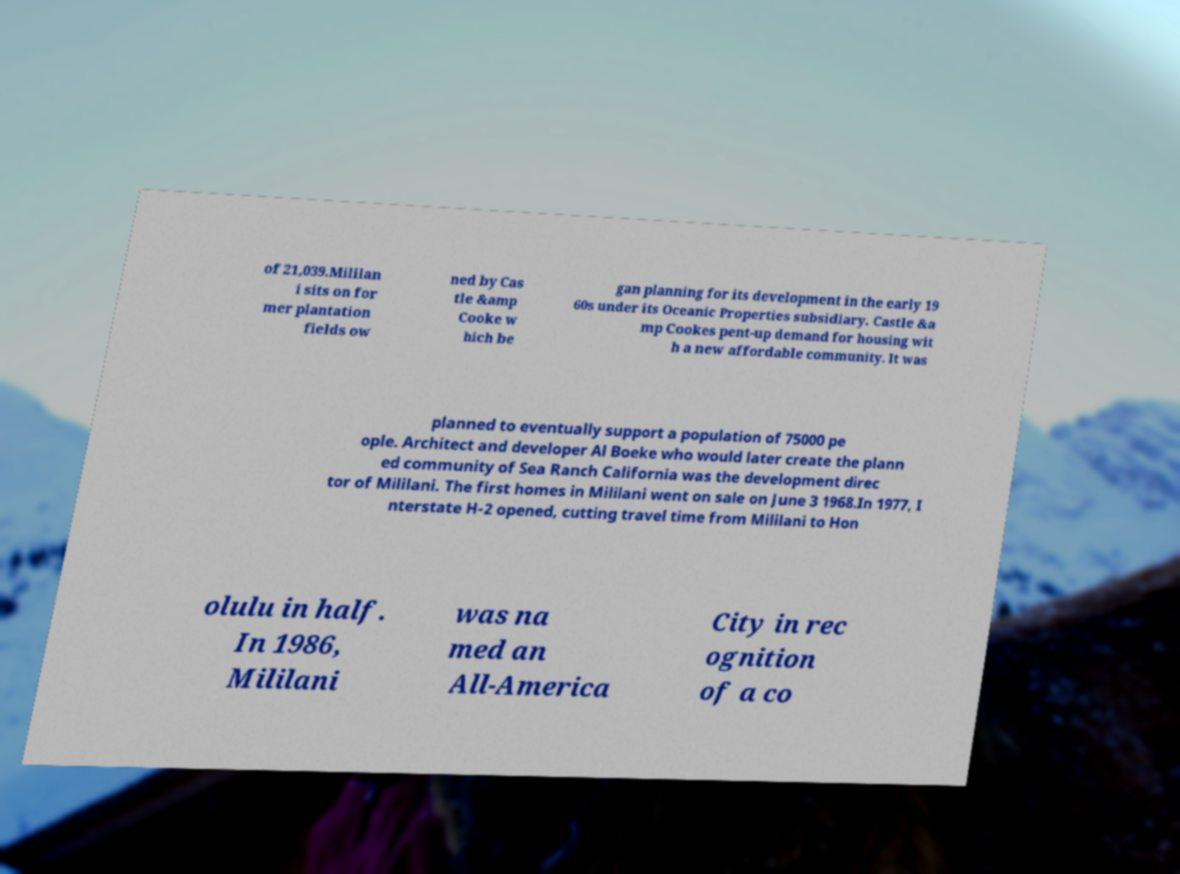Can you accurately transcribe the text from the provided image for me? of 21,039.Mililan i sits on for mer plantation fields ow ned by Cas tle &amp Cooke w hich be gan planning for its development in the early 19 60s under its Oceanic Properties subsidiary. Castle &a mp Cookes pent-up demand for housing wit h a new affordable community. It was planned to eventually support a population of 75000 pe ople. Architect and developer Al Boeke who would later create the plann ed community of Sea Ranch California was the development direc tor of Mililani. The first homes in Mililani went on sale on June 3 1968.In 1977, I nterstate H-2 opened, cutting travel time from Mililani to Hon olulu in half. In 1986, Mililani was na med an All-America City in rec ognition of a co 